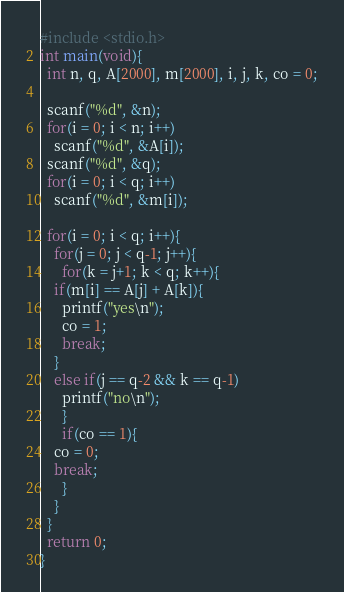<code> <loc_0><loc_0><loc_500><loc_500><_C_>#include <stdio.h>
int main(void){
  int n, q, A[2000], m[2000], i, j, k, co = 0;

  scanf("%d", &n);
  for(i = 0; i < n; i++)
    scanf("%d", &A[i]);
  scanf("%d", &q);
  for(i = 0; i < q; i++)
    scanf("%d", &m[i]);

  for(i = 0; i < q; i++){
    for(j = 0; j < q-1; j++){
      for(k = j+1; k < q; k++){
	if(m[i] == A[j] + A[k]){
	  printf("yes\n");
	  co = 1;
	  break;
	}
	else if(j == q-2 && k == q-1)
	  printf("no\n");
      }
      if(co == 1){
	co = 0;
	break;
      }
    }
  }
  return 0;
}</code> 